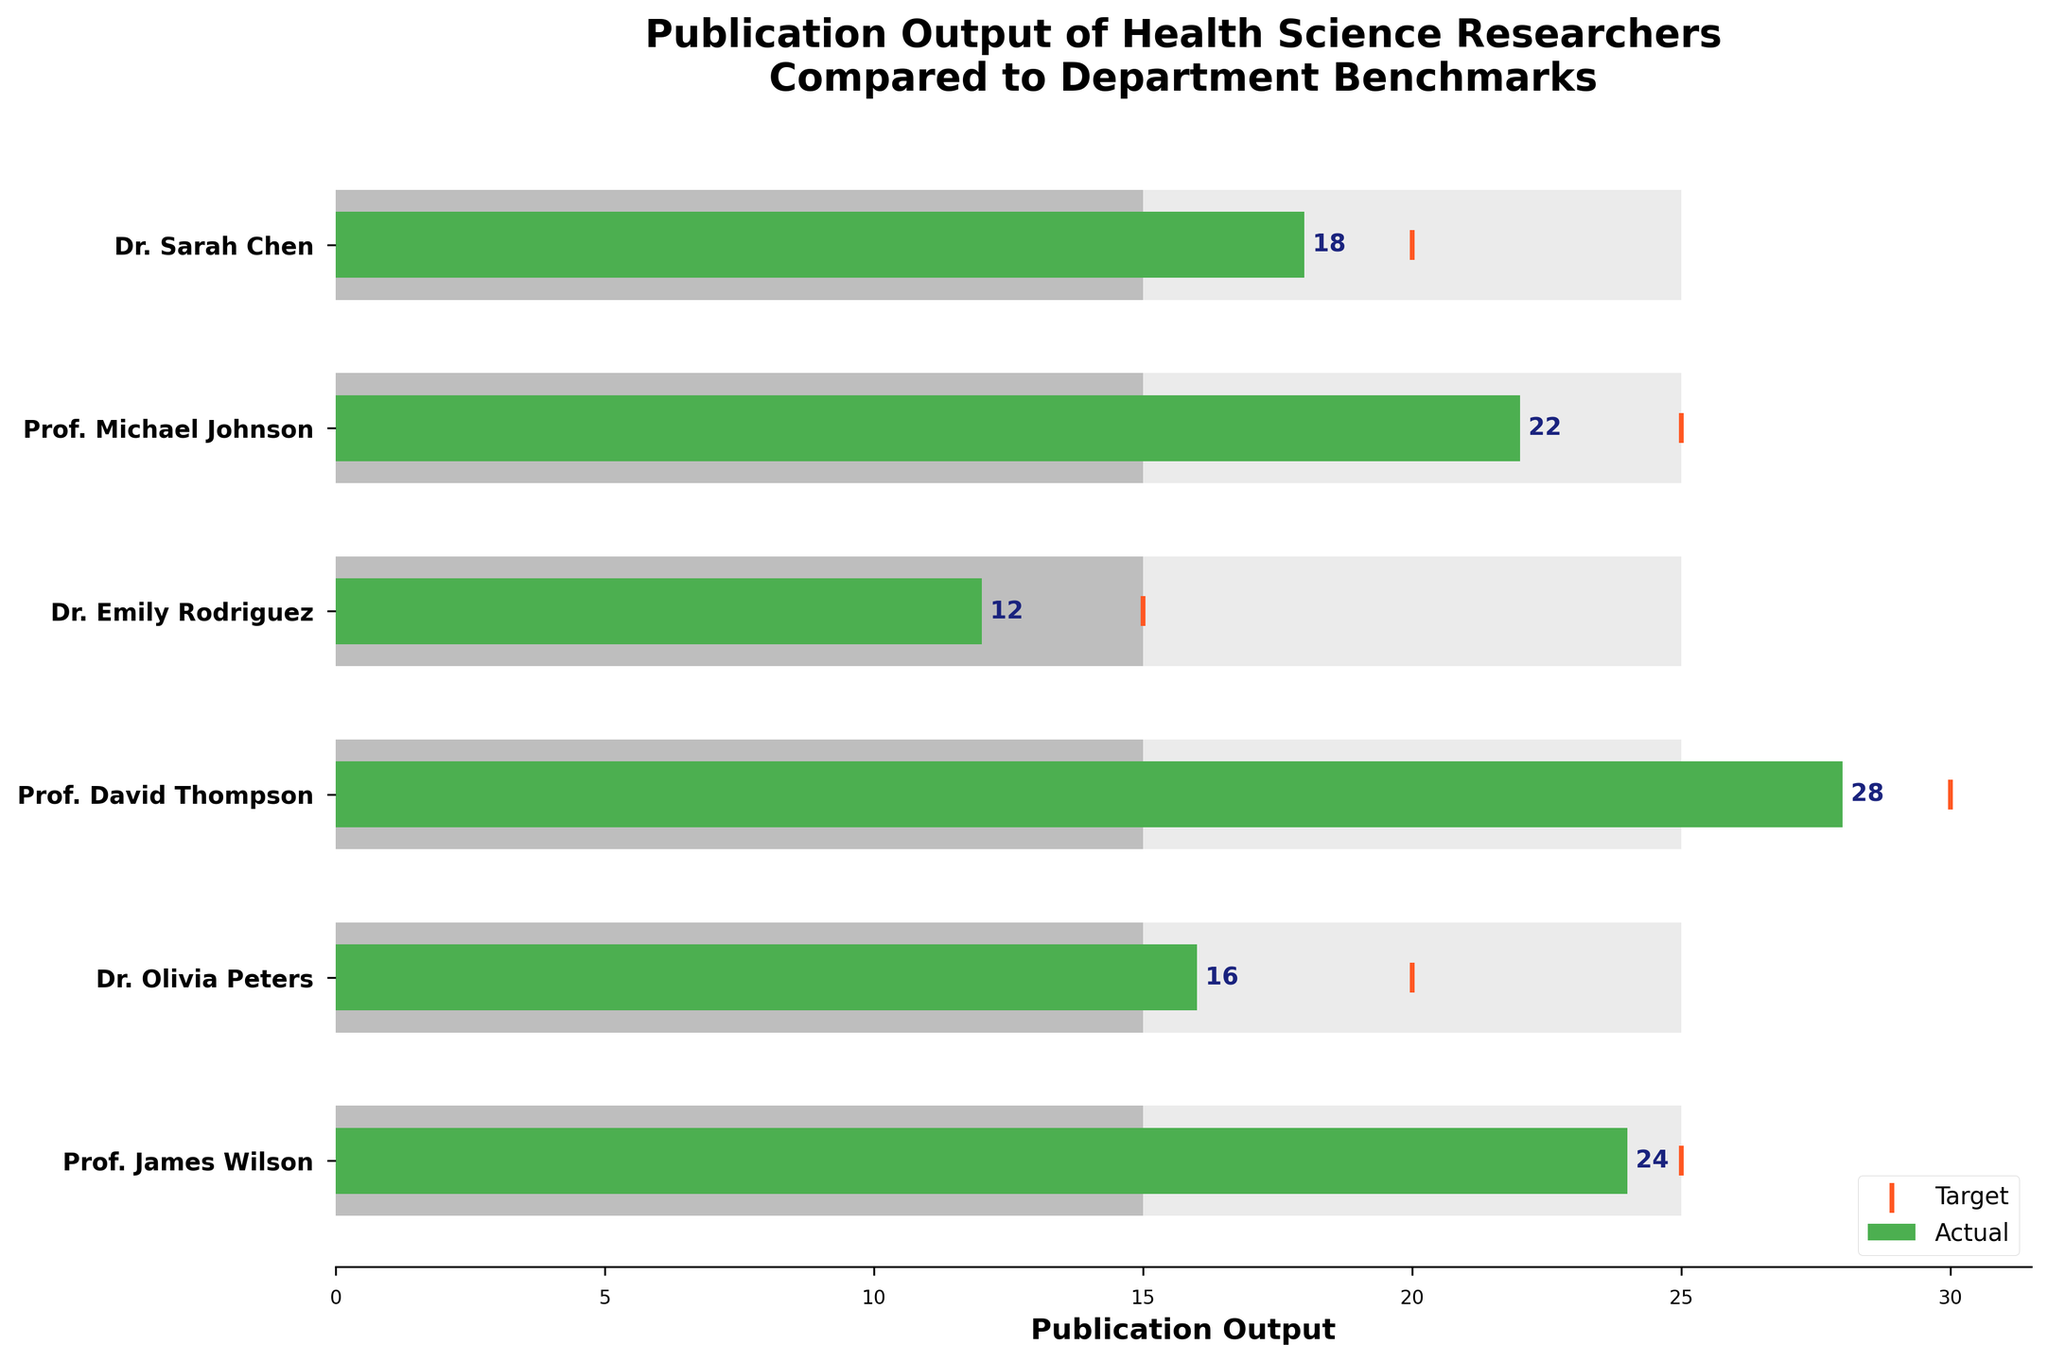What is the title of the figure? The title can be directly read from the top of the figure. By observing, we can see that it is clearly written.
Answer: Publication Output of Health Science Researchers Compared to Department Benchmarks Which researcher had the highest actual publication output? By scanning the actual values on the horizontal bars, we can find the researcher with the highest value. Prof. David Thompson's bar extends the farthest to the right, indicating the highest actual output.
Answer: Prof. David Thompson How many researchers met or exceeded their target publication output? To answer this, we need to compare the actual values to their respective target values for each researcher. Upon checking, we find Dr. Sarah Chen, Prof. Michael Johnson, Prof. James Wilson, and Prof. David Thompson met or exceeded their targets.
Answer: Four What is the difference between the actual and target publication output of Prof. Michael Johnson? We need to subtract the target value from the actual value for Prof. Michael Johnson. The actual is 22, and the target is 25. The difference is 22 - 25.
Answer: -3 Which researcher is closest to their target publication output? We need to evaluate the difference between actual and target for each researcher and find the smallest absolute difference. Dr. Olivia Peters' actual and target values are 16 and 20, with a difference of 4, the smallest among all.
Answer: Dr. Olivia Peters In which range do all researchers fall in terms of average benchmark for the department? By checking the "Average" bars for all researchers, we can see they all align at the value of 15, indicating they all fall in the same range of departmental averages.
Answer: 15 What fraction of researchers have actual publications above the departmental benchmark average? We count the number of researchers whose actual publications are greater than 15 and divide by the total number of researchers (6). The count is 4 (Dr. Sarah Chen, Prof. Michael Johnson, Prof. David Thompson, and Prof. James Wilson). So, 4/6.
Answer: 2/3 Who is the most outstanding researcher according to their actual publications? By comparing the actual values to the outstanding benchmark (25) and observing whose actual bar is nearest or overlaps with this benchmark, Prof. David Thompson has the highest and closest considering an actual value of 28.
Answer: Prof. David Thompson How does Dr. Emily Rodriguez's actual publication output compare to the departmental average benchmark? Dr. Emily Rodriguez's actual publication output is 12, while the departmental average benchmark is 15. Therefore, 12 - 15 is -3, indicating her output is below the average benchmark.
Answer: Below What is the total target publication output for all researchers combined? We sum up all the target values: 20 + 25 + 15 + 30 + 20 + 25. The total is 135.
Answer: 135 